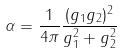Convert formula to latex. <formula><loc_0><loc_0><loc_500><loc_500>\alpha = \frac { 1 } { 4 \pi } \frac { ( g _ { 1 } g _ { 2 } ) ^ { 2 } } { g _ { 1 } ^ { 2 } + g _ { 2 } ^ { 2 } }</formula> 